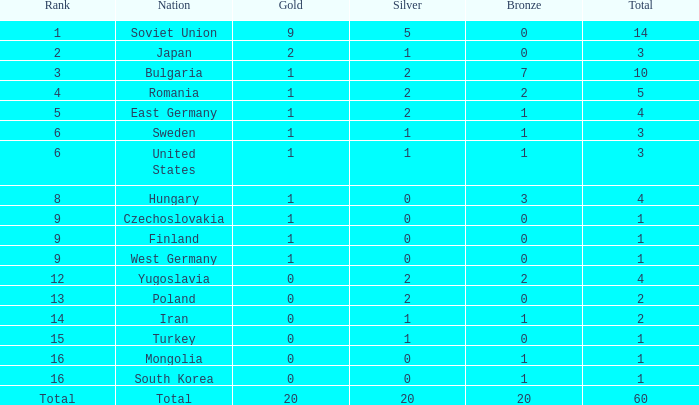What is the number of totals that have silvers under 2, bronzes over 0, and golds over 1? 0.0. 